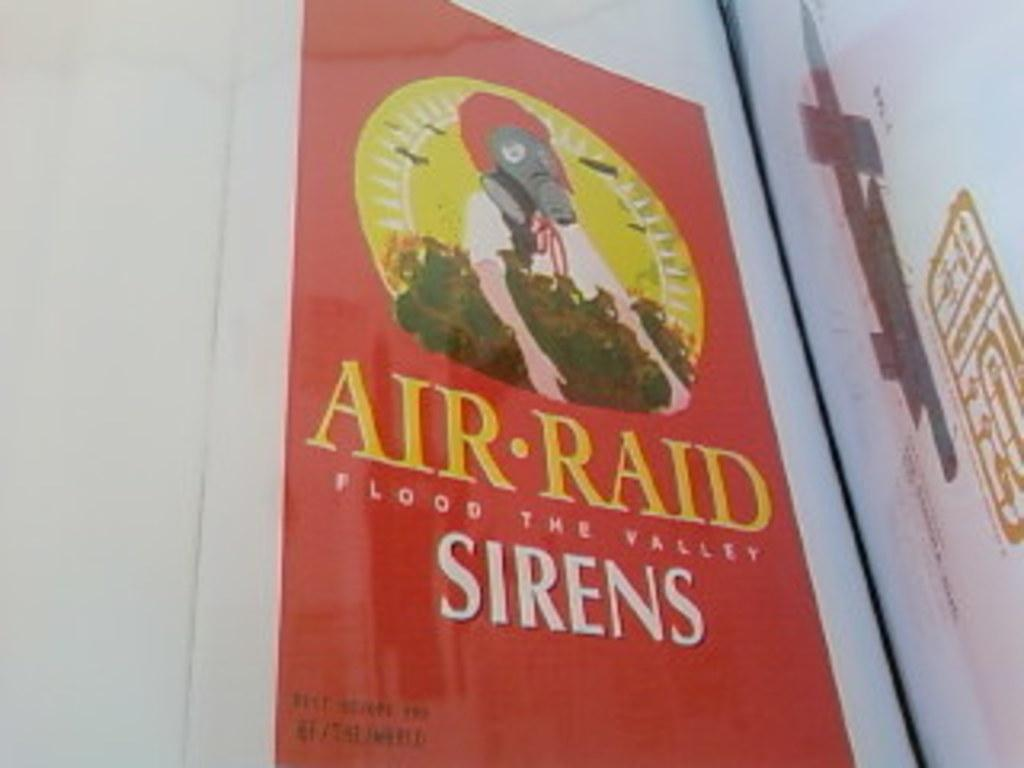Provide a one-sentence caption for the provided image. The Air Raid Sirens poster is a parody of the original poster. 